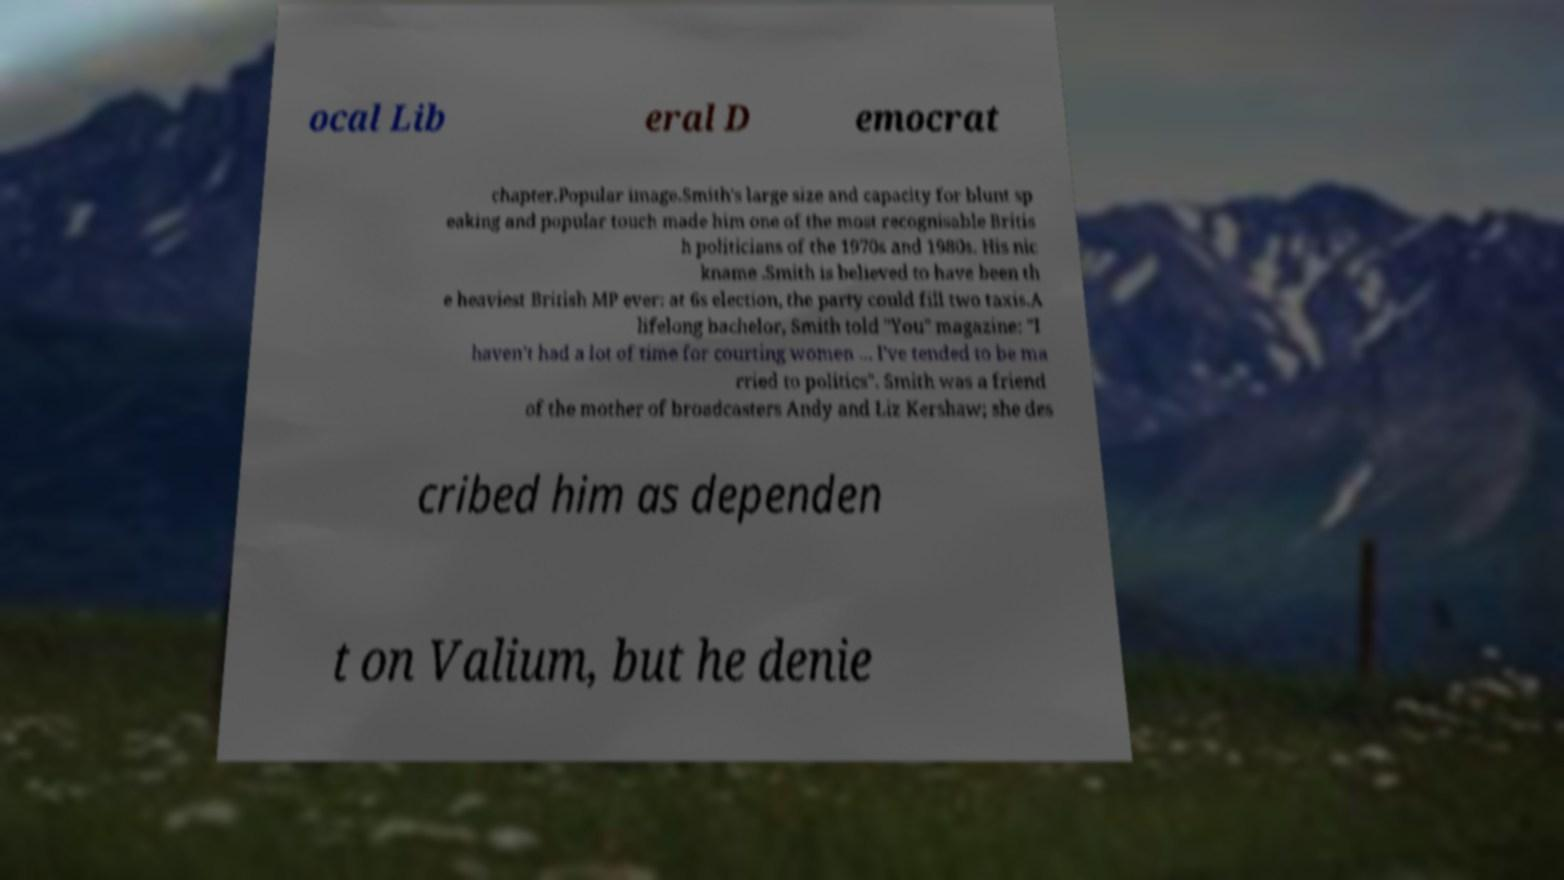Could you assist in decoding the text presented in this image and type it out clearly? ocal Lib eral D emocrat chapter.Popular image.Smith's large size and capacity for blunt sp eaking and popular touch made him one of the most recognisable Britis h politicians of the 1970s and 1980s. His nic kname .Smith is believed to have been th e heaviest British MP ever: at 6s election, the party could fill two taxis.A lifelong bachelor, Smith told "You" magazine: "I haven't had a lot of time for courting women ... I've tended to be ma rried to politics". Smith was a friend of the mother of broadcasters Andy and Liz Kershaw; she des cribed him as dependen t on Valium, but he denie 